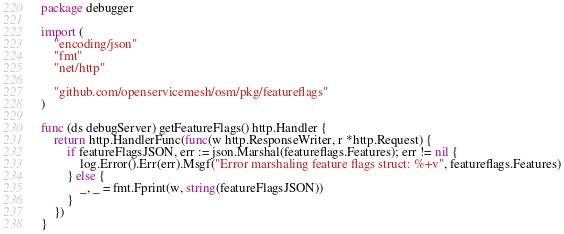Convert code to text. <code><loc_0><loc_0><loc_500><loc_500><_Go_>package debugger

import (
	"encoding/json"
	"fmt"
	"net/http"

	"github.com/openservicemesh/osm/pkg/featureflags"
)

func (ds debugServer) getFeatureFlags() http.Handler {
	return http.HandlerFunc(func(w http.ResponseWriter, r *http.Request) {
		if featureFlagsJSON, err := json.Marshal(featureflags.Features); err != nil {
			log.Error().Err(err).Msgf("Error marshaling feature flags struct: %+v", featureflags.Features)
		} else {
			_, _ = fmt.Fprint(w, string(featureFlagsJSON))
		}
	})
}
</code> 